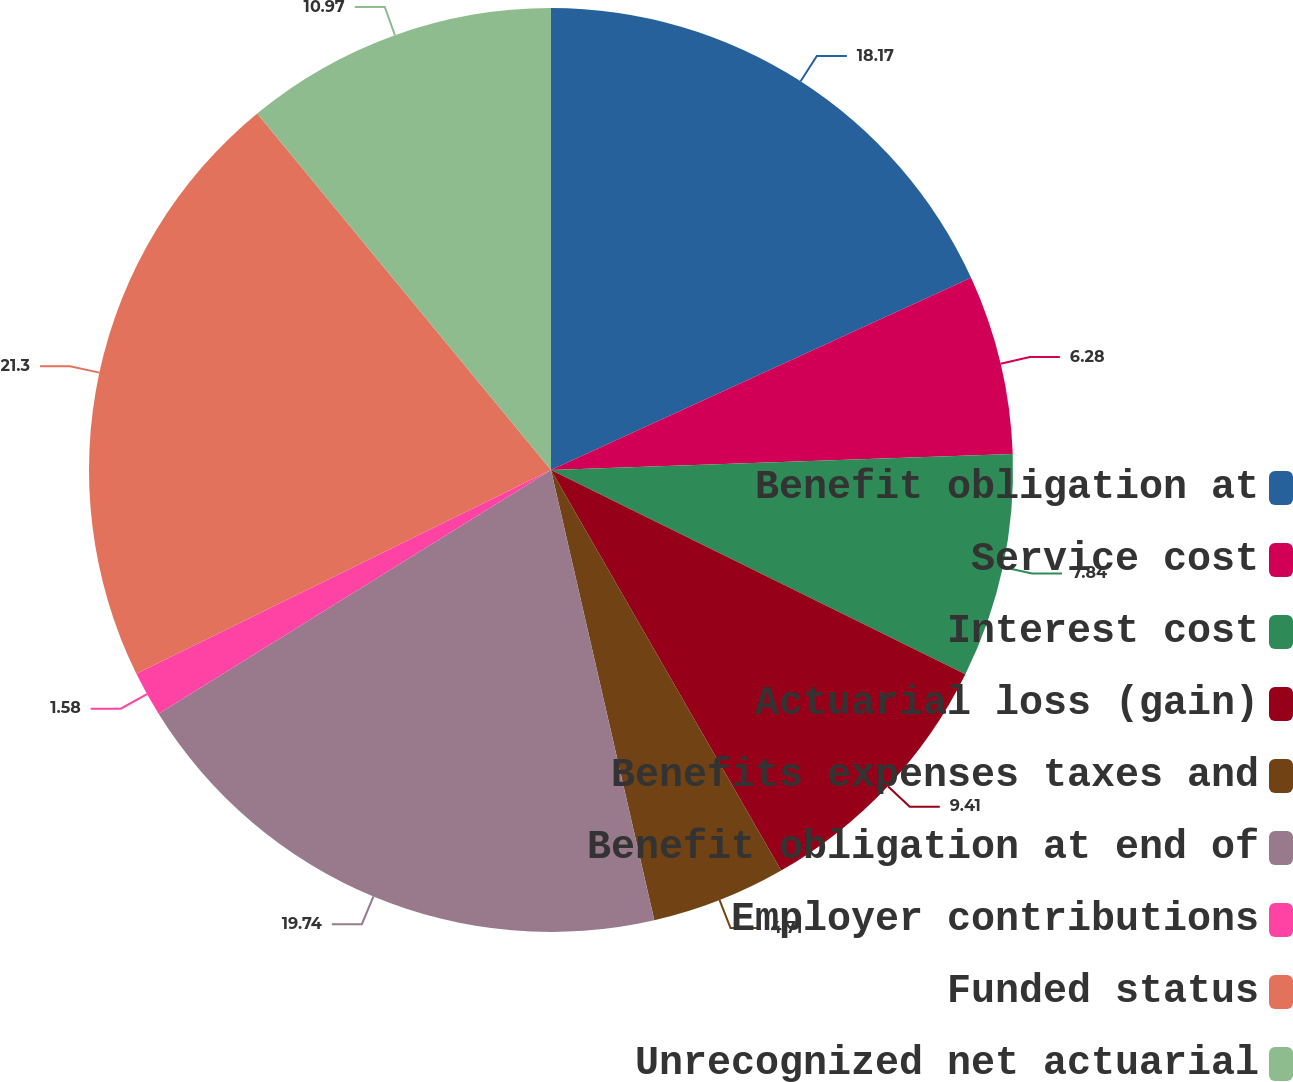Convert chart to OTSL. <chart><loc_0><loc_0><loc_500><loc_500><pie_chart><fcel>Benefit obligation at<fcel>Service cost<fcel>Interest cost<fcel>Actuarial loss (gain)<fcel>Benefits expenses taxes and<fcel>Benefit obligation at end of<fcel>Employer contributions<fcel>Funded status<fcel>Unrecognized net actuarial<nl><fcel>18.17%<fcel>6.28%<fcel>7.84%<fcel>9.41%<fcel>4.71%<fcel>19.74%<fcel>1.58%<fcel>21.3%<fcel>10.97%<nl></chart> 